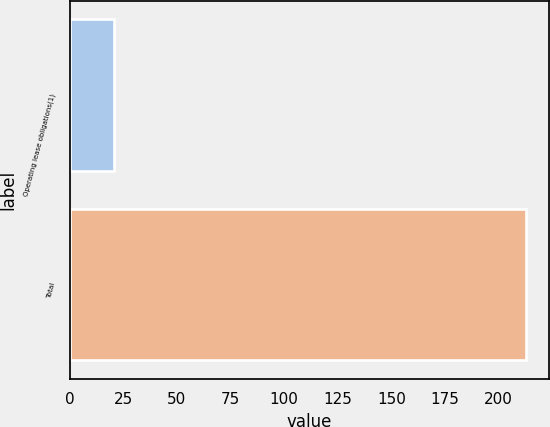<chart> <loc_0><loc_0><loc_500><loc_500><bar_chart><fcel>Operating lease obligations(1)<fcel>Total<nl><fcel>20.5<fcel>212.8<nl></chart> 